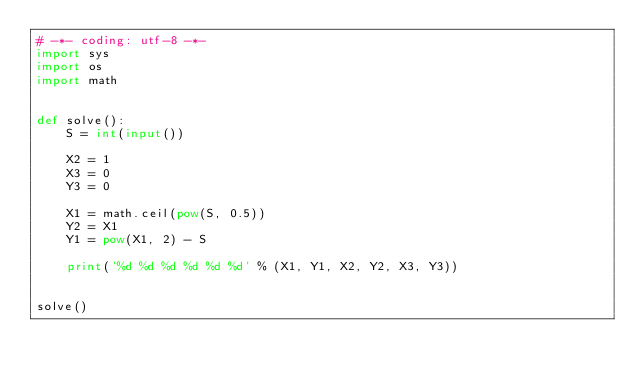Convert code to text. <code><loc_0><loc_0><loc_500><loc_500><_Python_># -*- coding: utf-8 -*-
import sys
import os
import math


def solve():
    S = int(input())

    X2 = 1
    X3 = 0
    Y3 = 0

    X1 = math.ceil(pow(S, 0.5))
    Y2 = X1
    Y1 = pow(X1, 2) - S

    print('%d %d %d %d %d %d' % (X1, Y1, X2, Y2, X3, Y3))


solve()
</code> 